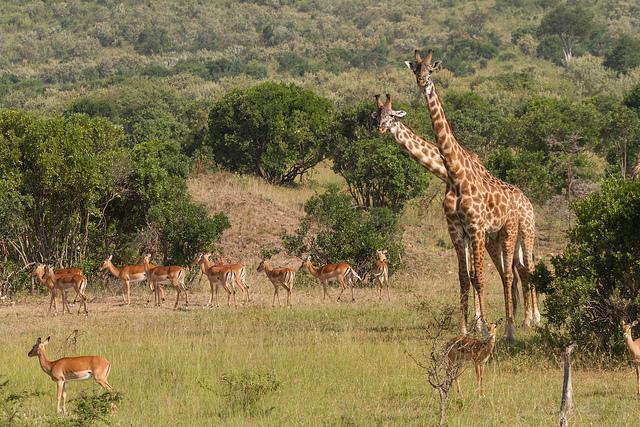How many giraffes are there?
Give a very brief answer. 2. How many giraffes are visible?
Give a very brief answer. 2. 